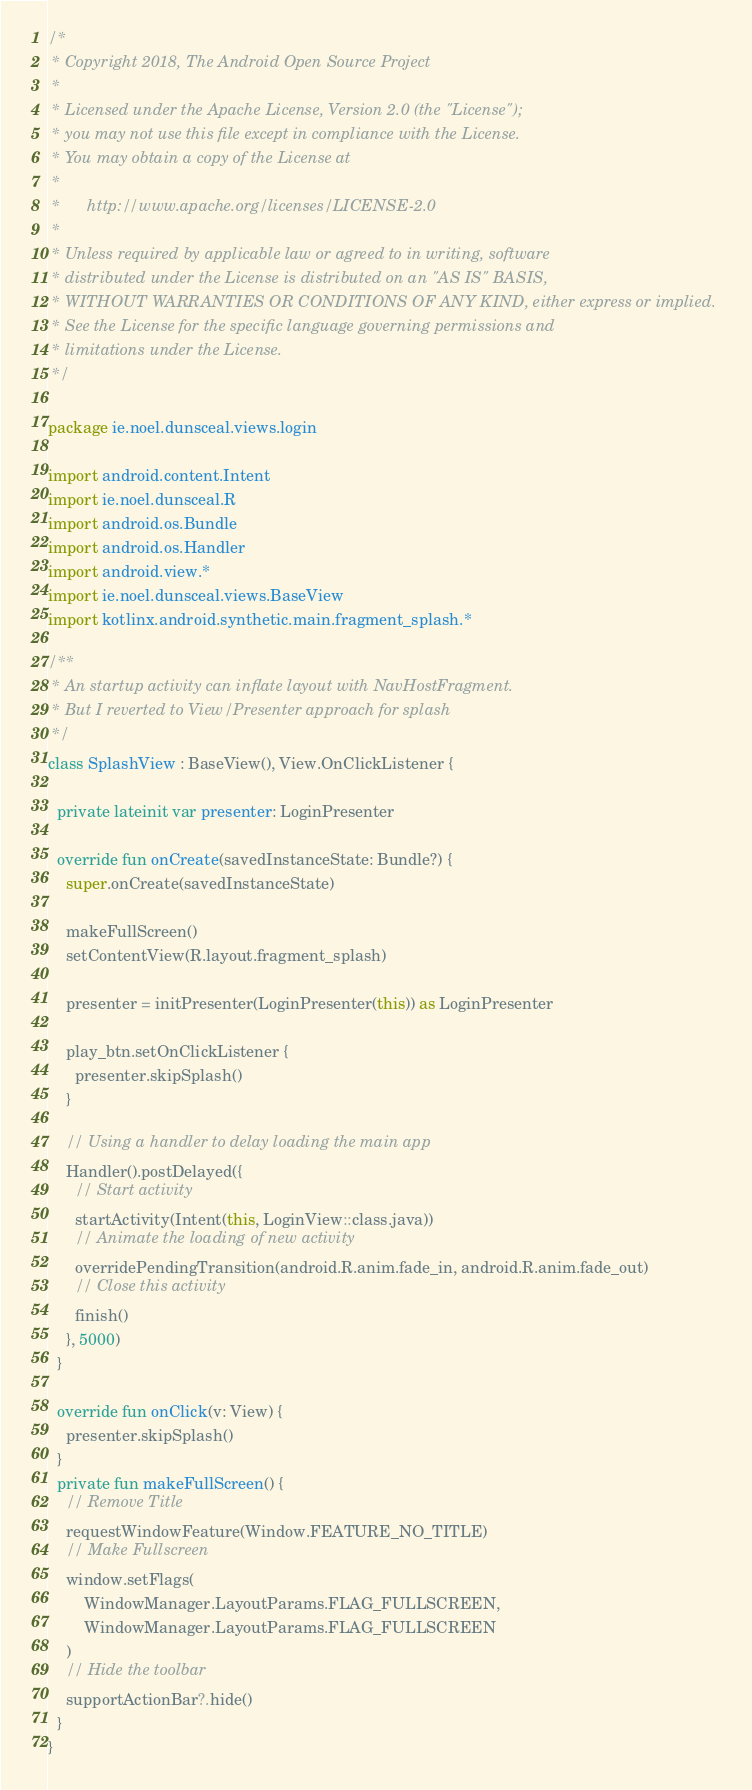<code> <loc_0><loc_0><loc_500><loc_500><_Kotlin_>/*
 * Copyright 2018, The Android Open Source Project
 *
 * Licensed under the Apache License, Version 2.0 (the "License");
 * you may not use this file except in compliance with the License.
 * You may obtain a copy of the License at
 *
 *      http://www.apache.org/licenses/LICENSE-2.0
 *
 * Unless required by applicable law or agreed to in writing, software
 * distributed under the License is distributed on an "AS IS" BASIS,
 * WITHOUT WARRANTIES OR CONDITIONS OF ANY KIND, either express or implied.
 * See the License for the specific language governing permissions and
 * limitations under the License.
 */

package ie.noel.dunsceal.views.login

import android.content.Intent
import ie.noel.dunsceal.R
import android.os.Bundle
import android.os.Handler
import android.view.*
import ie.noel.dunsceal.views.BaseView
import kotlinx.android.synthetic.main.fragment_splash.*

/**
 * An startup activity can inflate layout with NavHostFragment.
 * But I reverted to View/Presenter approach for splash
 */
class SplashView : BaseView(), View.OnClickListener {

  private lateinit var presenter: LoginPresenter

  override fun onCreate(savedInstanceState: Bundle?) {
    super.onCreate(savedInstanceState)

    makeFullScreen()
    setContentView(R.layout.fragment_splash)

    presenter = initPresenter(LoginPresenter(this)) as LoginPresenter

    play_btn.setOnClickListener {
      presenter.skipSplash()
    }

    // Using a handler to delay loading the main app
    Handler().postDelayed({
      // Start activity
      startActivity(Intent(this, LoginView::class.java))
      // Animate the loading of new activity
      overridePendingTransition(android.R.anim.fade_in, android.R.anim.fade_out)
      // Close this activity
      finish()
    }, 5000)
  }

  override fun onClick(v: View) {
    presenter.skipSplash()
  }
  private fun makeFullScreen() {
    // Remove Title
    requestWindowFeature(Window.FEATURE_NO_TITLE)
    // Make Fullscreen
    window.setFlags(
        WindowManager.LayoutParams.FLAG_FULLSCREEN,
        WindowManager.LayoutParams.FLAG_FULLSCREEN
    )
    // Hide the toolbar
    supportActionBar?.hide()
  }
}</code> 